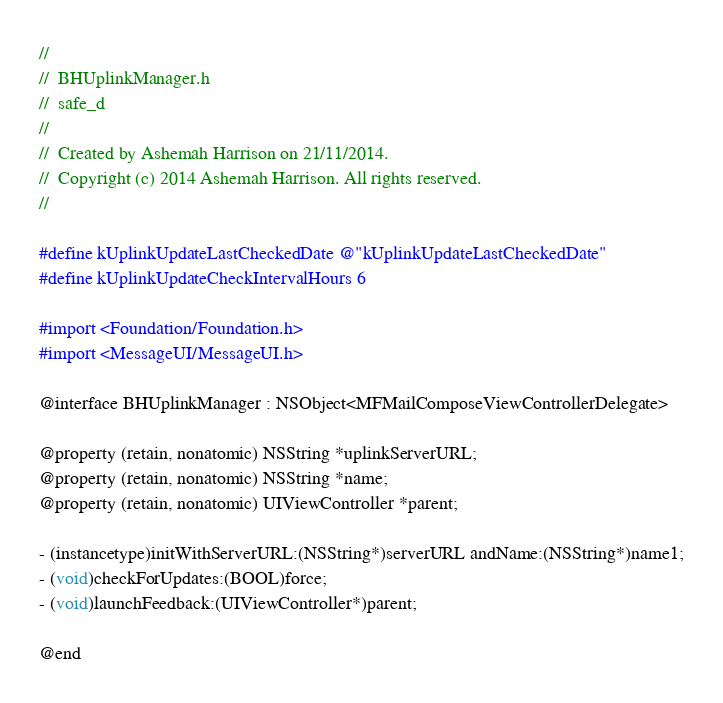Convert code to text. <code><loc_0><loc_0><loc_500><loc_500><_C_>//
//  BHUplinkManager.h
//  safe_d
//
//  Created by Ashemah Harrison on 21/11/2014.
//  Copyright (c) 2014 Ashemah Harrison. All rights reserved.
//

#define kUplinkUpdateLastCheckedDate @"kUplinkUpdateLastCheckedDate"
#define kUplinkUpdateCheckIntervalHours 6

#import <Foundation/Foundation.h>
#import <MessageUI/MessageUI.h> 

@interface BHUplinkManager : NSObject<MFMailComposeViewControllerDelegate>

@property (retain, nonatomic) NSString *uplinkServerURL;
@property (retain, nonatomic) NSString *name;
@property (retain, nonatomic) UIViewController *parent;

- (instancetype)initWithServerURL:(NSString*)serverURL andName:(NSString*)name1;
- (void)checkForUpdates:(BOOL)force;
- (void)launchFeedback:(UIViewController*)parent;

@end
</code> 